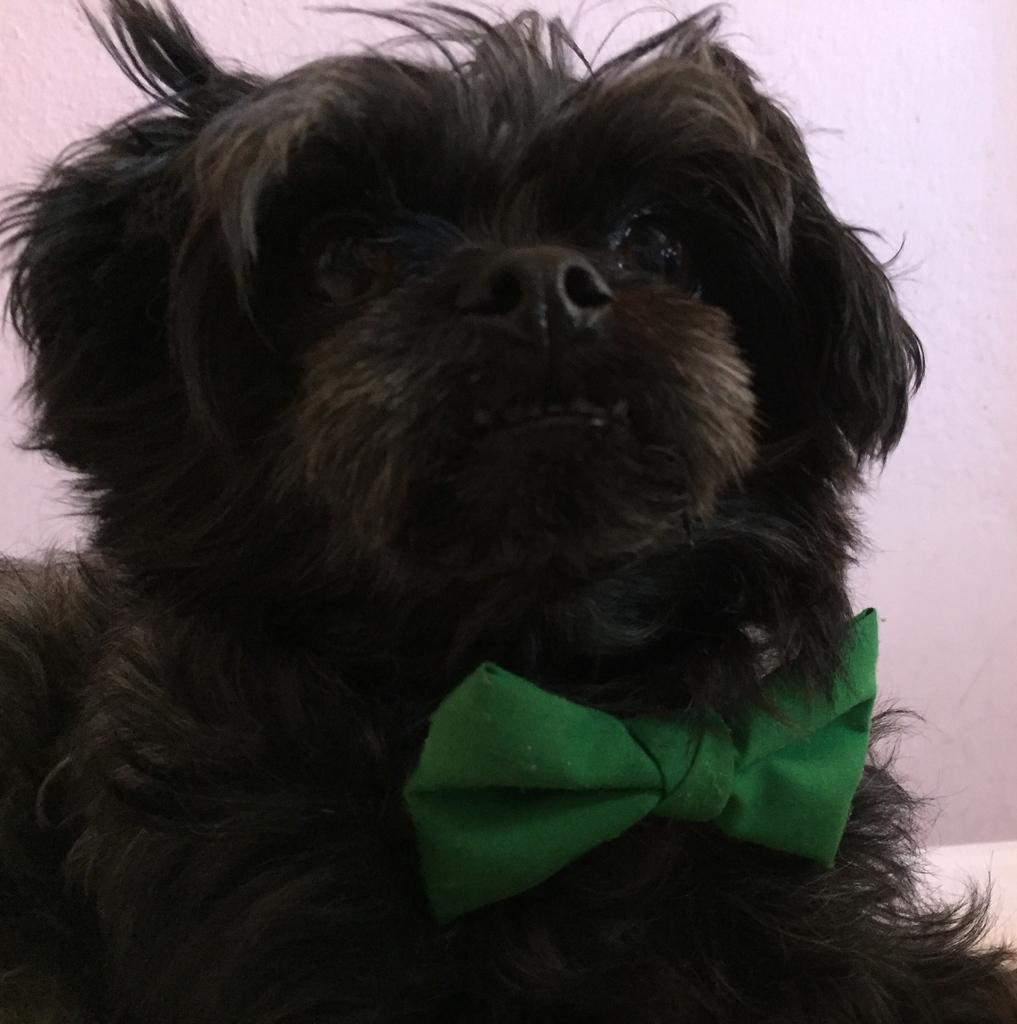What type of animal is in the image? There is a black color dog in the image. What is the dog wearing? The dog is wearing a green color bow tie. What can be seen in the background of the image? There is a wall in the background of the image. What shape is the pickle on the tray in the image? There is no pickle or tray present in the image. What type of square object can be seen near the dog? There is no square object near the dog in the image. 